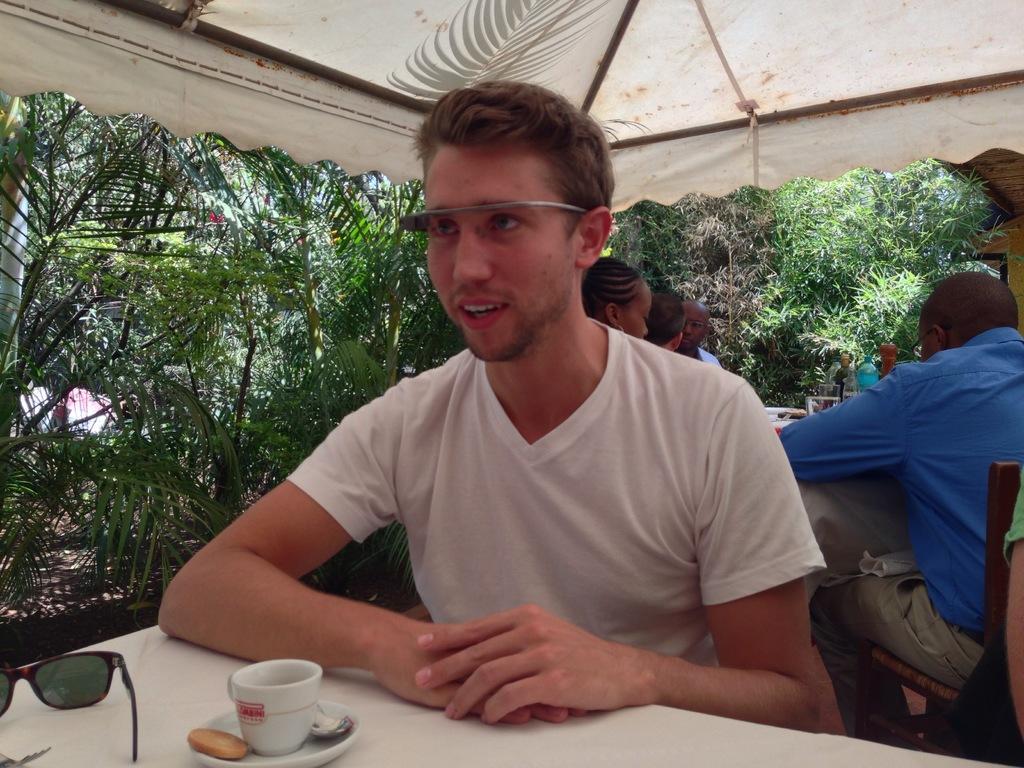Can you describe this image briefly? In the foreground of this image, there is a man wearing white T shirt is sitting in front of a table on which, there is a saucer, biscuit, cup and the spectacles. In the background, there are persons sitting on the chairs near a table, trees and the tent on the top. 